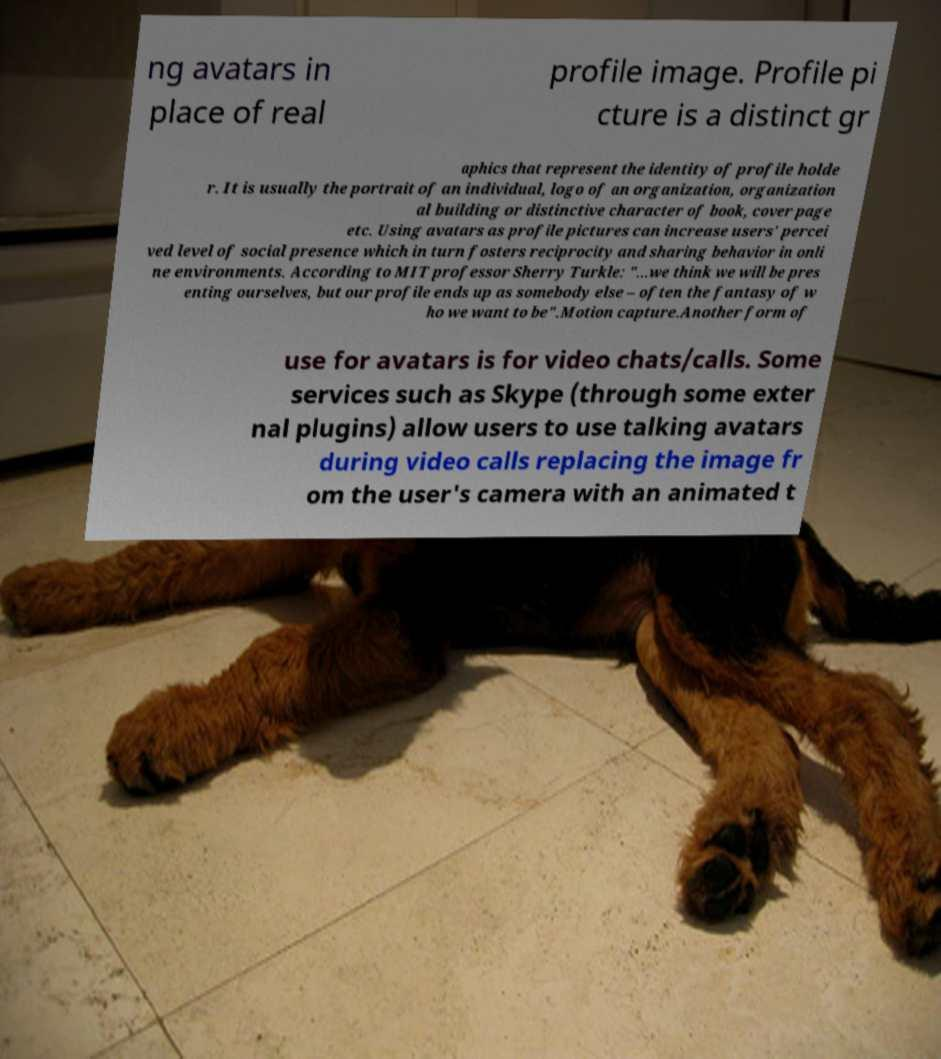There's text embedded in this image that I need extracted. Can you transcribe it verbatim? ng avatars in place of real profile image. Profile pi cture is a distinct gr aphics that represent the identity of profile holde r. It is usually the portrait of an individual, logo of an organization, organization al building or distinctive character of book, cover page etc. Using avatars as profile pictures can increase users' percei ved level of social presence which in turn fosters reciprocity and sharing behavior in onli ne environments. According to MIT professor Sherry Turkle: "...we think we will be pres enting ourselves, but our profile ends up as somebody else – often the fantasy of w ho we want to be".Motion capture.Another form of use for avatars is for video chats/calls. Some services such as Skype (through some exter nal plugins) allow users to use talking avatars during video calls replacing the image fr om the user's camera with an animated t 